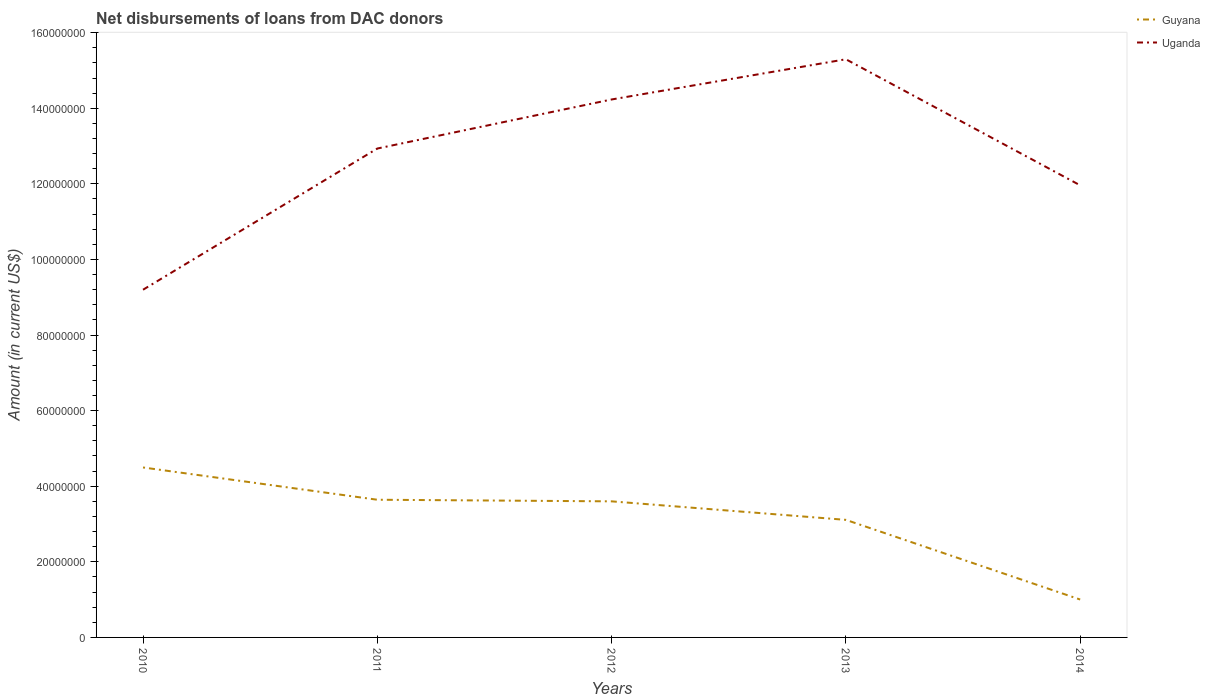Does the line corresponding to Uganda intersect with the line corresponding to Guyana?
Give a very brief answer. No. Is the number of lines equal to the number of legend labels?
Your answer should be very brief. Yes. Across all years, what is the maximum amount of loans disbursed in Guyana?
Ensure brevity in your answer.  1.00e+07. What is the total amount of loans disbursed in Guyana in the graph?
Keep it short and to the point. 2.64e+07. What is the difference between the highest and the second highest amount of loans disbursed in Guyana?
Give a very brief answer. 3.49e+07. What is the difference between the highest and the lowest amount of loans disbursed in Uganda?
Provide a short and direct response. 3. What is the difference between two consecutive major ticks on the Y-axis?
Offer a very short reply. 2.00e+07. Does the graph contain grids?
Keep it short and to the point. No. How many legend labels are there?
Give a very brief answer. 2. How are the legend labels stacked?
Make the answer very short. Vertical. What is the title of the graph?
Make the answer very short. Net disbursements of loans from DAC donors. What is the label or title of the Y-axis?
Provide a succinct answer. Amount (in current US$). What is the Amount (in current US$) of Guyana in 2010?
Offer a very short reply. 4.50e+07. What is the Amount (in current US$) of Uganda in 2010?
Offer a terse response. 9.20e+07. What is the Amount (in current US$) of Guyana in 2011?
Give a very brief answer. 3.64e+07. What is the Amount (in current US$) in Uganda in 2011?
Your answer should be very brief. 1.29e+08. What is the Amount (in current US$) of Guyana in 2012?
Provide a succinct answer. 3.60e+07. What is the Amount (in current US$) in Uganda in 2012?
Provide a succinct answer. 1.42e+08. What is the Amount (in current US$) of Guyana in 2013?
Your response must be concise. 3.11e+07. What is the Amount (in current US$) in Uganda in 2013?
Ensure brevity in your answer.  1.53e+08. What is the Amount (in current US$) of Guyana in 2014?
Make the answer very short. 1.00e+07. What is the Amount (in current US$) in Uganda in 2014?
Give a very brief answer. 1.20e+08. Across all years, what is the maximum Amount (in current US$) in Guyana?
Make the answer very short. 4.50e+07. Across all years, what is the maximum Amount (in current US$) of Uganda?
Ensure brevity in your answer.  1.53e+08. Across all years, what is the minimum Amount (in current US$) of Guyana?
Provide a succinct answer. 1.00e+07. Across all years, what is the minimum Amount (in current US$) in Uganda?
Your response must be concise. 9.20e+07. What is the total Amount (in current US$) of Guyana in the graph?
Offer a terse response. 1.59e+08. What is the total Amount (in current US$) in Uganda in the graph?
Ensure brevity in your answer.  6.36e+08. What is the difference between the Amount (in current US$) of Guyana in 2010 and that in 2011?
Offer a very short reply. 8.54e+06. What is the difference between the Amount (in current US$) of Uganda in 2010 and that in 2011?
Offer a terse response. -3.74e+07. What is the difference between the Amount (in current US$) of Guyana in 2010 and that in 2012?
Your answer should be very brief. 8.96e+06. What is the difference between the Amount (in current US$) in Uganda in 2010 and that in 2012?
Offer a terse response. -5.03e+07. What is the difference between the Amount (in current US$) in Guyana in 2010 and that in 2013?
Offer a terse response. 1.39e+07. What is the difference between the Amount (in current US$) in Uganda in 2010 and that in 2013?
Make the answer very short. -6.10e+07. What is the difference between the Amount (in current US$) of Guyana in 2010 and that in 2014?
Ensure brevity in your answer.  3.49e+07. What is the difference between the Amount (in current US$) in Uganda in 2010 and that in 2014?
Provide a succinct answer. -2.76e+07. What is the difference between the Amount (in current US$) of Guyana in 2011 and that in 2012?
Offer a terse response. 4.26e+05. What is the difference between the Amount (in current US$) in Uganda in 2011 and that in 2012?
Ensure brevity in your answer.  -1.30e+07. What is the difference between the Amount (in current US$) of Guyana in 2011 and that in 2013?
Give a very brief answer. 5.32e+06. What is the difference between the Amount (in current US$) of Uganda in 2011 and that in 2013?
Make the answer very short. -2.36e+07. What is the difference between the Amount (in current US$) of Guyana in 2011 and that in 2014?
Provide a short and direct response. 2.64e+07. What is the difference between the Amount (in current US$) in Uganda in 2011 and that in 2014?
Your response must be concise. 9.73e+06. What is the difference between the Amount (in current US$) of Guyana in 2012 and that in 2013?
Your answer should be compact. 4.90e+06. What is the difference between the Amount (in current US$) in Uganda in 2012 and that in 2013?
Make the answer very short. -1.06e+07. What is the difference between the Amount (in current US$) of Guyana in 2012 and that in 2014?
Your answer should be very brief. 2.60e+07. What is the difference between the Amount (in current US$) of Uganda in 2012 and that in 2014?
Keep it short and to the point. 2.27e+07. What is the difference between the Amount (in current US$) of Guyana in 2013 and that in 2014?
Offer a very short reply. 2.11e+07. What is the difference between the Amount (in current US$) in Uganda in 2013 and that in 2014?
Make the answer very short. 3.33e+07. What is the difference between the Amount (in current US$) of Guyana in 2010 and the Amount (in current US$) of Uganda in 2011?
Offer a very short reply. -8.44e+07. What is the difference between the Amount (in current US$) of Guyana in 2010 and the Amount (in current US$) of Uganda in 2012?
Your answer should be very brief. -9.74e+07. What is the difference between the Amount (in current US$) in Guyana in 2010 and the Amount (in current US$) in Uganda in 2013?
Keep it short and to the point. -1.08e+08. What is the difference between the Amount (in current US$) in Guyana in 2010 and the Amount (in current US$) in Uganda in 2014?
Your answer should be very brief. -7.46e+07. What is the difference between the Amount (in current US$) of Guyana in 2011 and the Amount (in current US$) of Uganda in 2012?
Your answer should be very brief. -1.06e+08. What is the difference between the Amount (in current US$) in Guyana in 2011 and the Amount (in current US$) in Uganda in 2013?
Offer a very short reply. -1.17e+08. What is the difference between the Amount (in current US$) of Guyana in 2011 and the Amount (in current US$) of Uganda in 2014?
Keep it short and to the point. -8.32e+07. What is the difference between the Amount (in current US$) of Guyana in 2012 and the Amount (in current US$) of Uganda in 2013?
Keep it short and to the point. -1.17e+08. What is the difference between the Amount (in current US$) in Guyana in 2012 and the Amount (in current US$) in Uganda in 2014?
Ensure brevity in your answer.  -8.36e+07. What is the difference between the Amount (in current US$) of Guyana in 2013 and the Amount (in current US$) of Uganda in 2014?
Ensure brevity in your answer.  -8.85e+07. What is the average Amount (in current US$) of Guyana per year?
Offer a terse response. 3.17e+07. What is the average Amount (in current US$) of Uganda per year?
Provide a short and direct response. 1.27e+08. In the year 2010, what is the difference between the Amount (in current US$) of Guyana and Amount (in current US$) of Uganda?
Keep it short and to the point. -4.70e+07. In the year 2011, what is the difference between the Amount (in current US$) in Guyana and Amount (in current US$) in Uganda?
Keep it short and to the point. -9.29e+07. In the year 2012, what is the difference between the Amount (in current US$) in Guyana and Amount (in current US$) in Uganda?
Make the answer very short. -1.06e+08. In the year 2013, what is the difference between the Amount (in current US$) of Guyana and Amount (in current US$) of Uganda?
Your response must be concise. -1.22e+08. In the year 2014, what is the difference between the Amount (in current US$) of Guyana and Amount (in current US$) of Uganda?
Your answer should be very brief. -1.10e+08. What is the ratio of the Amount (in current US$) in Guyana in 2010 to that in 2011?
Offer a very short reply. 1.23. What is the ratio of the Amount (in current US$) in Uganda in 2010 to that in 2011?
Your answer should be compact. 0.71. What is the ratio of the Amount (in current US$) of Guyana in 2010 to that in 2012?
Offer a very short reply. 1.25. What is the ratio of the Amount (in current US$) of Uganda in 2010 to that in 2012?
Make the answer very short. 0.65. What is the ratio of the Amount (in current US$) in Guyana in 2010 to that in 2013?
Provide a short and direct response. 1.45. What is the ratio of the Amount (in current US$) in Uganda in 2010 to that in 2013?
Your response must be concise. 0.6. What is the ratio of the Amount (in current US$) of Guyana in 2010 to that in 2014?
Your response must be concise. 4.48. What is the ratio of the Amount (in current US$) of Uganda in 2010 to that in 2014?
Your answer should be compact. 0.77. What is the ratio of the Amount (in current US$) in Guyana in 2011 to that in 2012?
Make the answer very short. 1.01. What is the ratio of the Amount (in current US$) in Uganda in 2011 to that in 2012?
Your answer should be very brief. 0.91. What is the ratio of the Amount (in current US$) of Guyana in 2011 to that in 2013?
Your answer should be compact. 1.17. What is the ratio of the Amount (in current US$) in Uganda in 2011 to that in 2013?
Keep it short and to the point. 0.85. What is the ratio of the Amount (in current US$) in Guyana in 2011 to that in 2014?
Ensure brevity in your answer.  3.63. What is the ratio of the Amount (in current US$) of Uganda in 2011 to that in 2014?
Provide a short and direct response. 1.08. What is the ratio of the Amount (in current US$) in Guyana in 2012 to that in 2013?
Ensure brevity in your answer.  1.16. What is the ratio of the Amount (in current US$) of Uganda in 2012 to that in 2013?
Make the answer very short. 0.93. What is the ratio of the Amount (in current US$) of Guyana in 2012 to that in 2014?
Offer a very short reply. 3.59. What is the ratio of the Amount (in current US$) of Uganda in 2012 to that in 2014?
Provide a succinct answer. 1.19. What is the ratio of the Amount (in current US$) of Guyana in 2013 to that in 2014?
Your answer should be very brief. 3.1. What is the ratio of the Amount (in current US$) of Uganda in 2013 to that in 2014?
Make the answer very short. 1.28. What is the difference between the highest and the second highest Amount (in current US$) of Guyana?
Your response must be concise. 8.54e+06. What is the difference between the highest and the second highest Amount (in current US$) of Uganda?
Your answer should be compact. 1.06e+07. What is the difference between the highest and the lowest Amount (in current US$) in Guyana?
Offer a very short reply. 3.49e+07. What is the difference between the highest and the lowest Amount (in current US$) in Uganda?
Provide a short and direct response. 6.10e+07. 